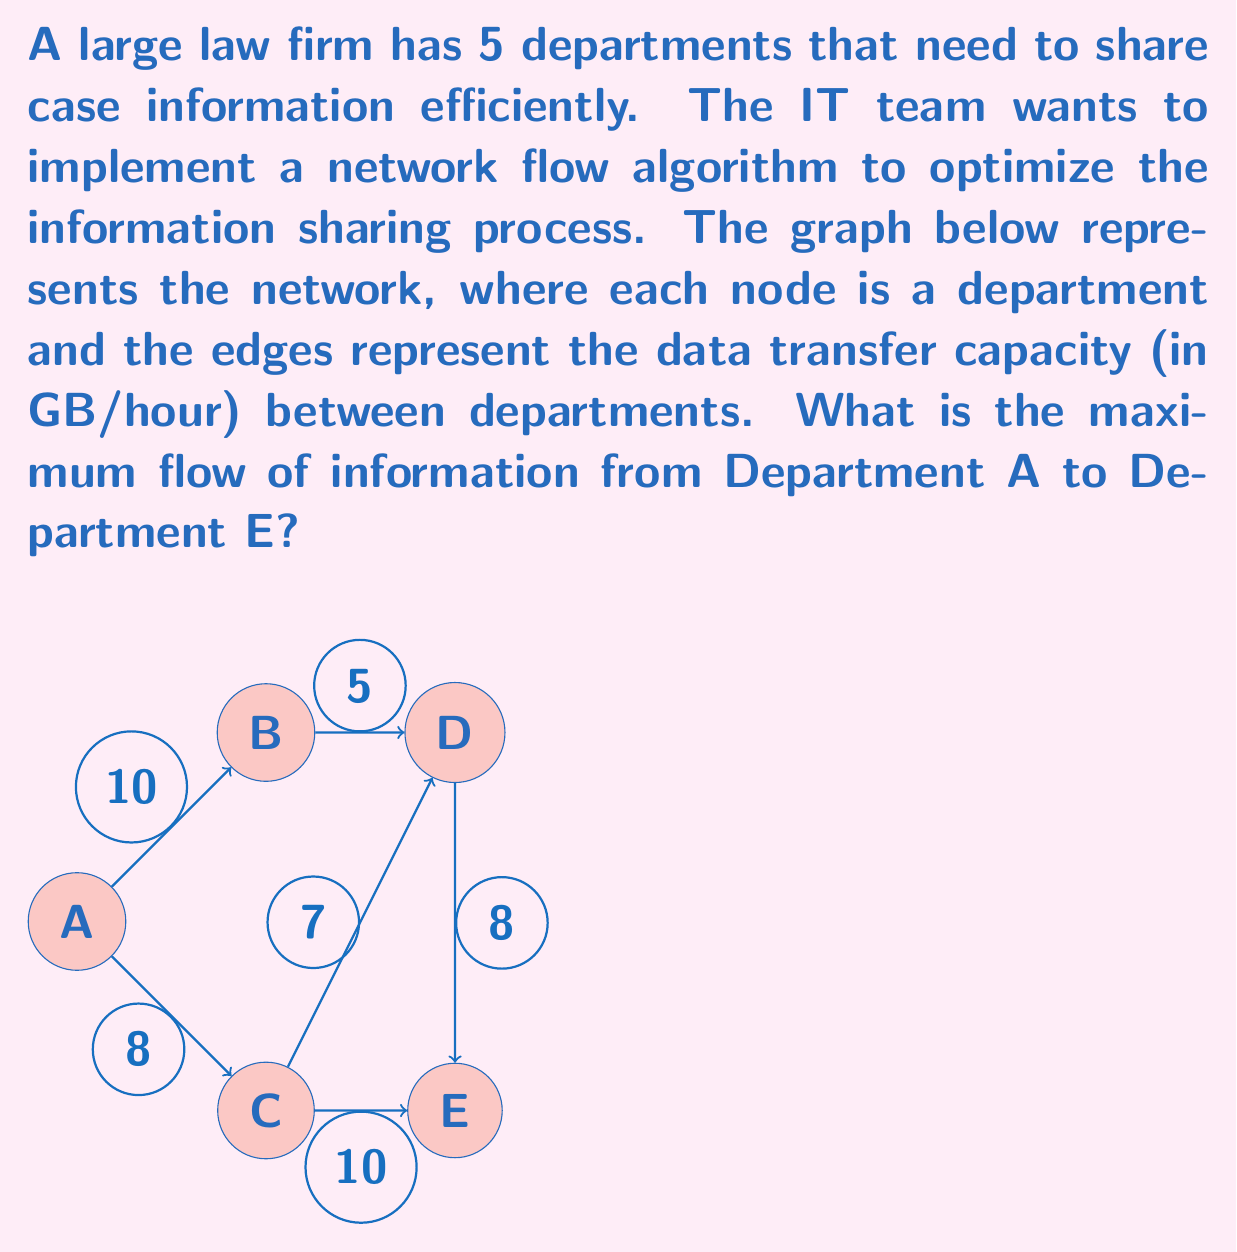Provide a solution to this math problem. To solve this network flow problem, we can use the Ford-Fulkerson algorithm or its improved version, the Edmonds-Karp algorithm. Here's a step-by-step explanation:

1) First, we identify the source (A) and the sink (E) in our network.

2) We then look for augmenting paths from A to E and add their flows until no more augmenting paths can be found.

3) Let's find the augmenting paths:

   Path 1: A -> B -> D -> E
   Bottleneck: min(10, 5, 8) = 5
   Flow: 5

   Path 2: A -> C -> E
   Bottleneck: min(8, 10) = 8
   Flow: 8

   Path 3: A -> C -> D -> E
   Remaining capacities: A->C: 0, C->D: 7, D->E: 3
   Bottleneck: min(0, 7, 3) = 0
   No more flow can be added through this path.

4) The maximum flow is the sum of the flows through all augmenting paths:
   
   Maximum Flow = 5 + 8 = 13 GB/hour

This result means that the network can transfer a maximum of 13 GB of information per hour from Department A to Department E, utilizing the optimal paths through the network.
Answer: The maximum flow of information from Department A to Department E is 13 GB/hour. 